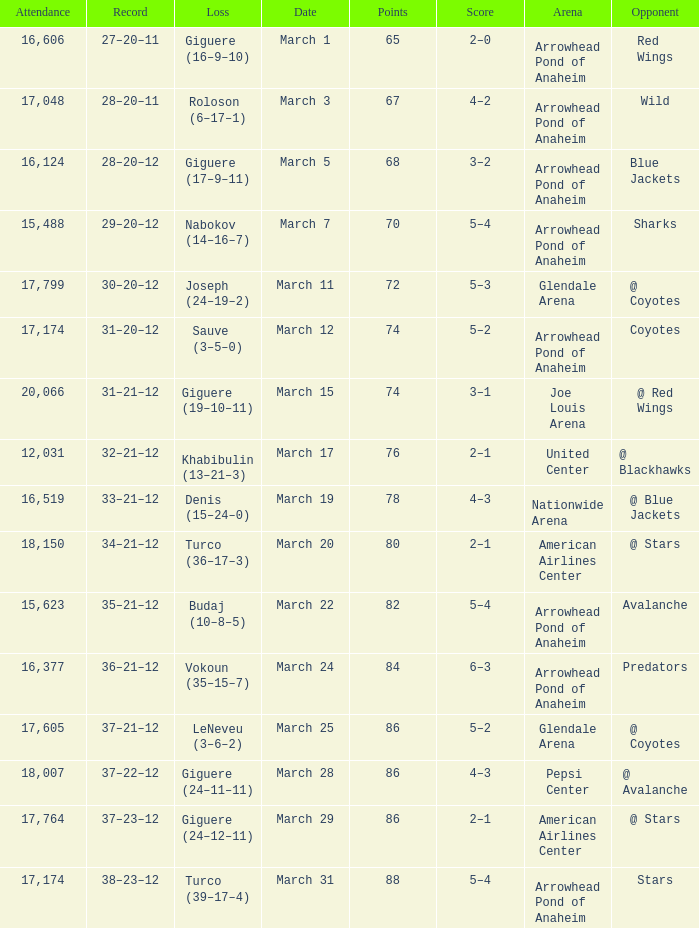What is the Attendance of the game with a Score of 3–2? 1.0. 